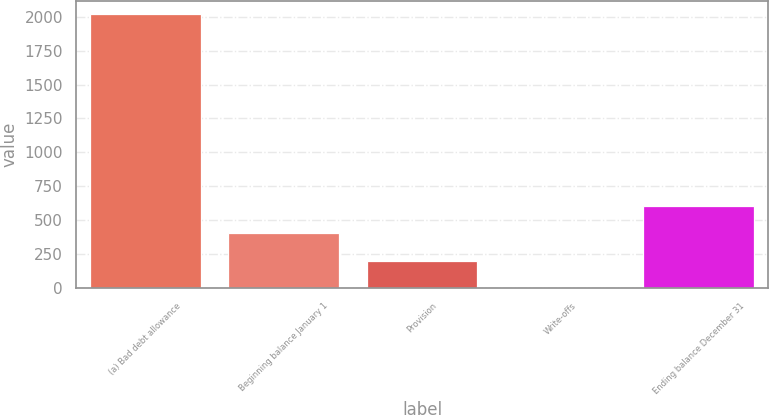Convert chart to OTSL. <chart><loc_0><loc_0><loc_500><loc_500><bar_chart><fcel>(a) Bad debt allowance<fcel>Beginning balance January 1<fcel>Provision<fcel>Write-offs<fcel>Ending balance December 31<nl><fcel>2017<fcel>403.48<fcel>201.79<fcel>0.1<fcel>605.17<nl></chart> 